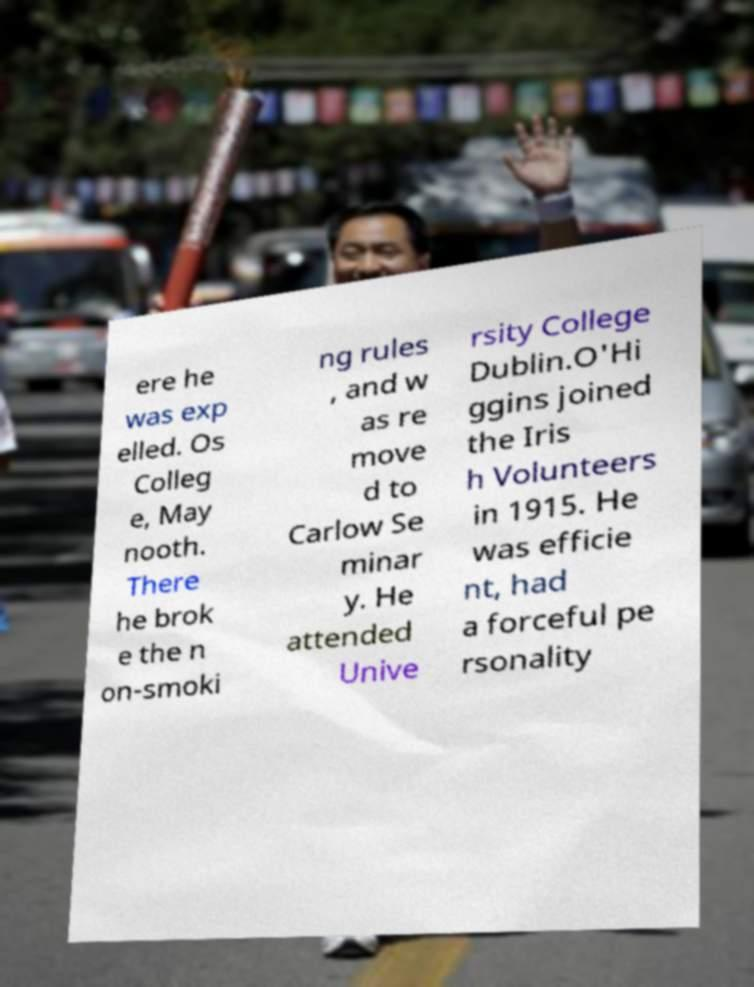Could you extract and type out the text from this image? ere he was exp elled. Os Colleg e, May nooth. There he brok e the n on-smoki ng rules , and w as re move d to Carlow Se minar y. He attended Unive rsity College Dublin.O'Hi ggins joined the Iris h Volunteers in 1915. He was efficie nt, had a forceful pe rsonality 